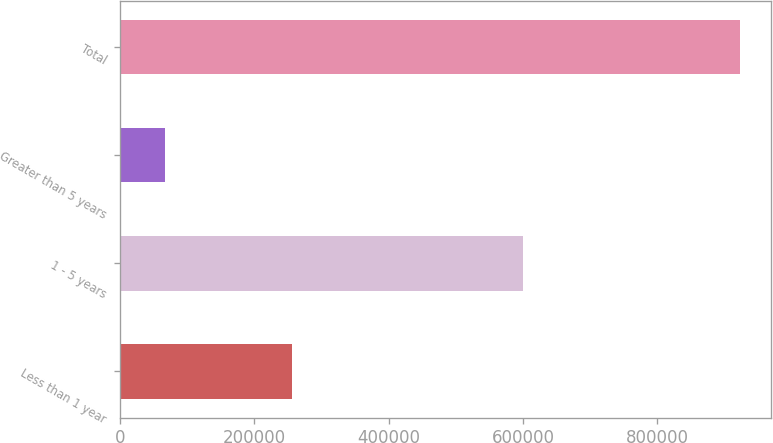Convert chart. <chart><loc_0><loc_0><loc_500><loc_500><bar_chart><fcel>Less than 1 year<fcel>1 - 5 years<fcel>Greater than 5 years<fcel>Total<nl><fcel>256741<fcel>599983<fcel>66753<fcel>923477<nl></chart> 